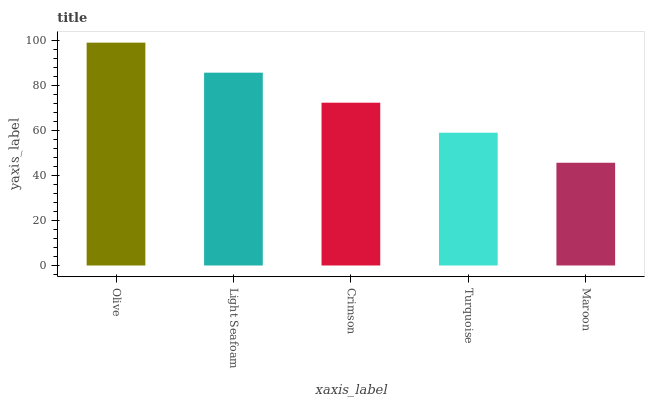Is Maroon the minimum?
Answer yes or no. Yes. Is Olive the maximum?
Answer yes or no. Yes. Is Light Seafoam the minimum?
Answer yes or no. No. Is Light Seafoam the maximum?
Answer yes or no. No. Is Olive greater than Light Seafoam?
Answer yes or no. Yes. Is Light Seafoam less than Olive?
Answer yes or no. Yes. Is Light Seafoam greater than Olive?
Answer yes or no. No. Is Olive less than Light Seafoam?
Answer yes or no. No. Is Crimson the high median?
Answer yes or no. Yes. Is Crimson the low median?
Answer yes or no. Yes. Is Light Seafoam the high median?
Answer yes or no. No. Is Turquoise the low median?
Answer yes or no. No. 